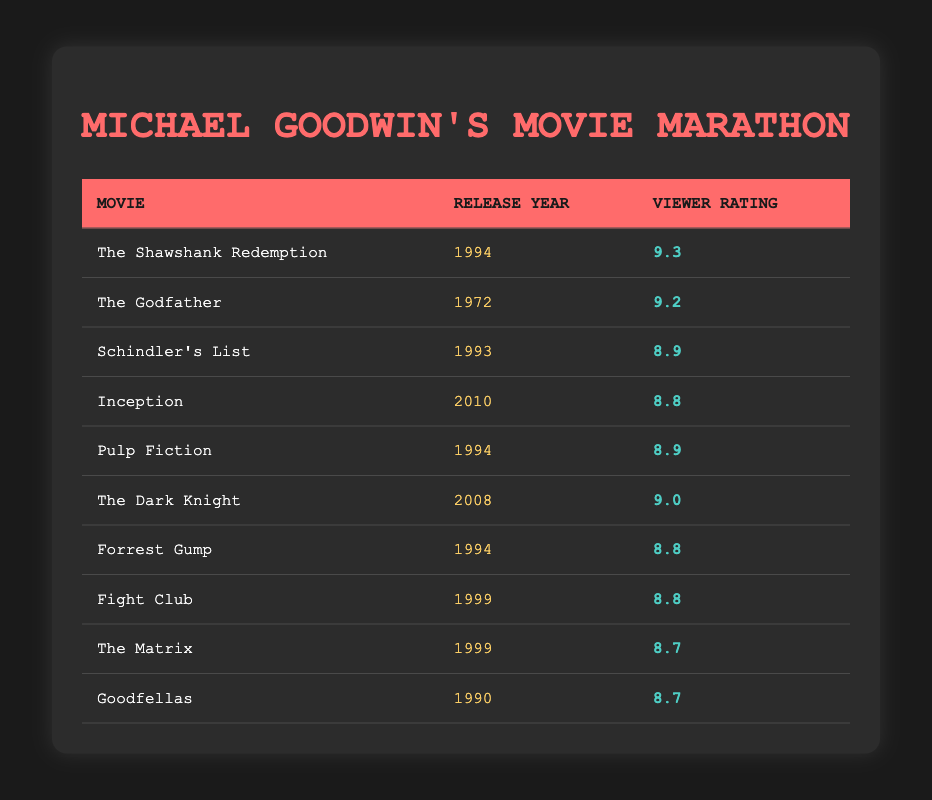What is the highest viewer rating in the table? The table lists various movies and their viewer ratings. By examining the ratings, "The Shawshank Redemption" has the highest rating of 9.3.
Answer: 9.3 Which movie released in 1994 has a viewer rating lower than 9.0? From the table, the movies released in 1994 are "The Shawshank Redemption" (9.3), "Pulp Fiction" (8.9), and "Forrest Gump" (8.8). Both "Pulp Fiction" and "Forrest Gump" have ratings lower than 9.0.
Answer: Pulp Fiction, Forrest Gump Is there a movie from 1999 that has a viewer rating higher than 8.8? The table lists two movies from 1999: "Fight Club" (8.8) and "The Matrix" (8.7). Both have ratings lower than 8.8, so no movie from that year meets the criteria.
Answer: No What is the average viewer rating of movies from the year 1994? The movies from 1994 are "The Shawshank Redemption" (9.3), "Pulp Fiction" (8.9), and "Forrest Gump" (8.8). The total rating is 9.3 + 8.9 + 8.8 = 27.0, and there are 3 movies. The average rating is therefore 27.0 / 3 = 9.0.
Answer: 9.0 Which movie has a viewer rating closest to 9.0 without exceeding it? Reviewing the table, "The Dark Knight" has a rating of 9.0, which matches the threshold. The next closest is "The Shawshank Redemption" at 9.3, which exceeds 9.0, thus making "The Dark Knight" the only movie that meets this criterion.
Answer: The Dark Knight 